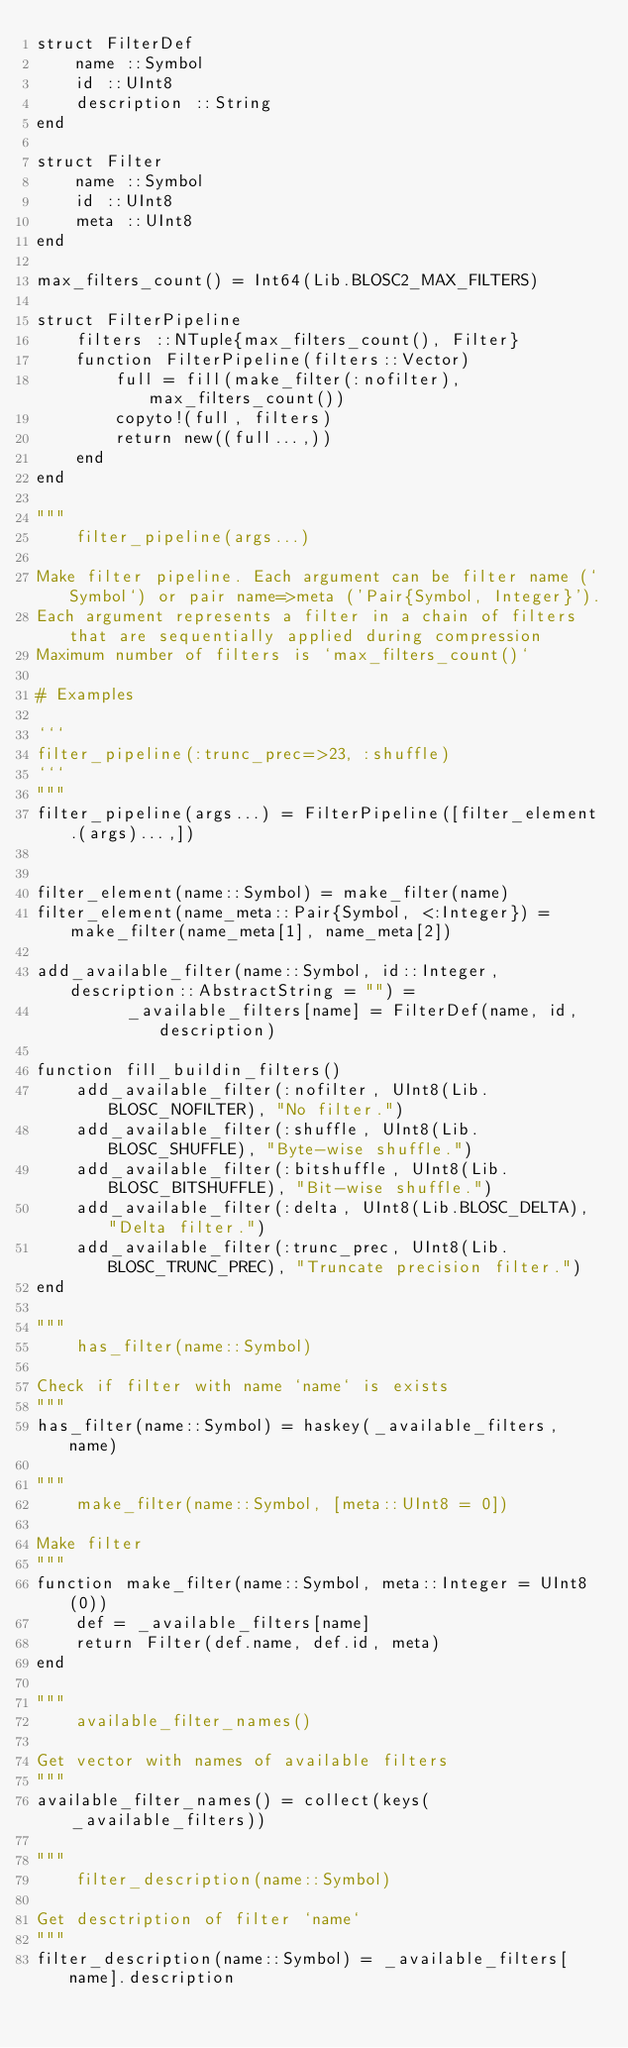<code> <loc_0><loc_0><loc_500><loc_500><_Julia_>struct FilterDef
    name ::Symbol
    id ::UInt8
    description ::String
end

struct Filter
    name ::Symbol
    id ::UInt8
    meta ::UInt8
end

max_filters_count() = Int64(Lib.BLOSC2_MAX_FILTERS)

struct FilterPipeline
    filters ::NTuple{max_filters_count(), Filter}
    function FilterPipeline(filters::Vector)
        full = fill(make_filter(:nofilter), max_filters_count())
        copyto!(full, filters)
        return new((full...,))
    end
end

"""
    filter_pipeline(args...)

Make filter pipeline. Each argument can be filter name (`Symbol`) or pair name=>meta ('Pair{Symbol, Integer}').
Each argument represents a filter in a chain of filters that are sequentially applied during compression
Maximum number of filters is `max_filters_count()`

# Examples

```
filter_pipeline(:trunc_prec=>23, :shuffle)
```
"""
filter_pipeline(args...) = FilterPipeline([filter_element.(args)...,])


filter_element(name::Symbol) = make_filter(name)
filter_element(name_meta::Pair{Symbol, <:Integer}) = make_filter(name_meta[1], name_meta[2])

add_available_filter(name::Symbol, id::Integer, description::AbstractString = "") =
         _available_filters[name] = FilterDef(name, id, description)

function fill_buildin_filters()
    add_available_filter(:nofilter, UInt8(Lib.BLOSC_NOFILTER), "No filter.")
    add_available_filter(:shuffle, UInt8(Lib.BLOSC_SHUFFLE), "Byte-wise shuffle.")
    add_available_filter(:bitshuffle, UInt8(Lib.BLOSC_BITSHUFFLE), "Bit-wise shuffle.")
    add_available_filter(:delta, UInt8(Lib.BLOSC_DELTA), "Delta filter.")
    add_available_filter(:trunc_prec, UInt8(Lib.BLOSC_TRUNC_PREC), "Truncate precision filter.")
end

"""
    has_filter(name::Symbol)

Check if filter with name `name` is exists
"""
has_filter(name::Symbol) = haskey(_available_filters, name)

"""
    make_filter(name::Symbol, [meta::UInt8 = 0])

Make filter
"""
function make_filter(name::Symbol, meta::Integer = UInt8(0))
    def = _available_filters[name]
    return Filter(def.name, def.id, meta)
end

"""
    available_filter_names()

Get vector with names of available filters
"""
available_filter_names() = collect(keys(_available_filters))

"""
    filter_description(name::Symbol)

Get desctription of filter `name`
"""
filter_description(name::Symbol) = _available_filters[name].description</code> 